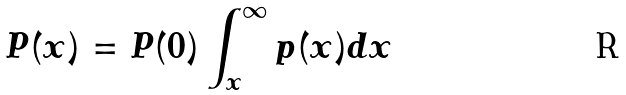<formula> <loc_0><loc_0><loc_500><loc_500>P ( x ) = { P ( 0 ) } \int _ { x } ^ { \infty } p ( x ) d x</formula> 